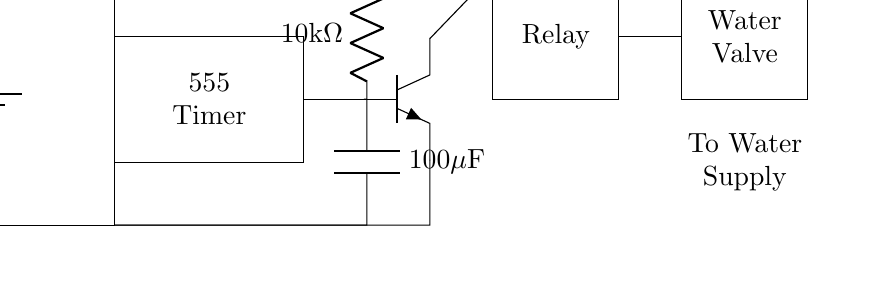what is the voltage of this circuit? The voltage is 5V, as indicated by the battery symbol in the circuit diagram.
Answer: 5V what type of transistor is used in this circuit? The circuit uses an NPN transistor, which is represented by the symbol with three leads: base, collector, and emitter, confirming its type.
Answer: NPN what is the resistance value in this circuit? The circuit shows a resistor with a value of 10k ohms, marked near the resistor symbol.
Answer: 10k ohm how many components are involved in this circuit? By counting the components in the diagram, which include the battery, timer, resistor, capacitor, transistor, relay, and water valve, there are a total of seven components.
Answer: Seven how does the timer activate the relay? The timer controls the transistor, which, when activated, allows current to flow from the collector to the emitter, energizing the relay and opening the water valve. This process connects the timer's output state to the relay’s coil.
Answer: Through the transistor what is the purpose of the capacitor in this circuit? The capacitor stores electrical energy and helps to stabilize the output of the timer by filtering voltage fluctuations, ensuring that the timer operates correctly over a set period of time.
Answer: To stabilize the timer 